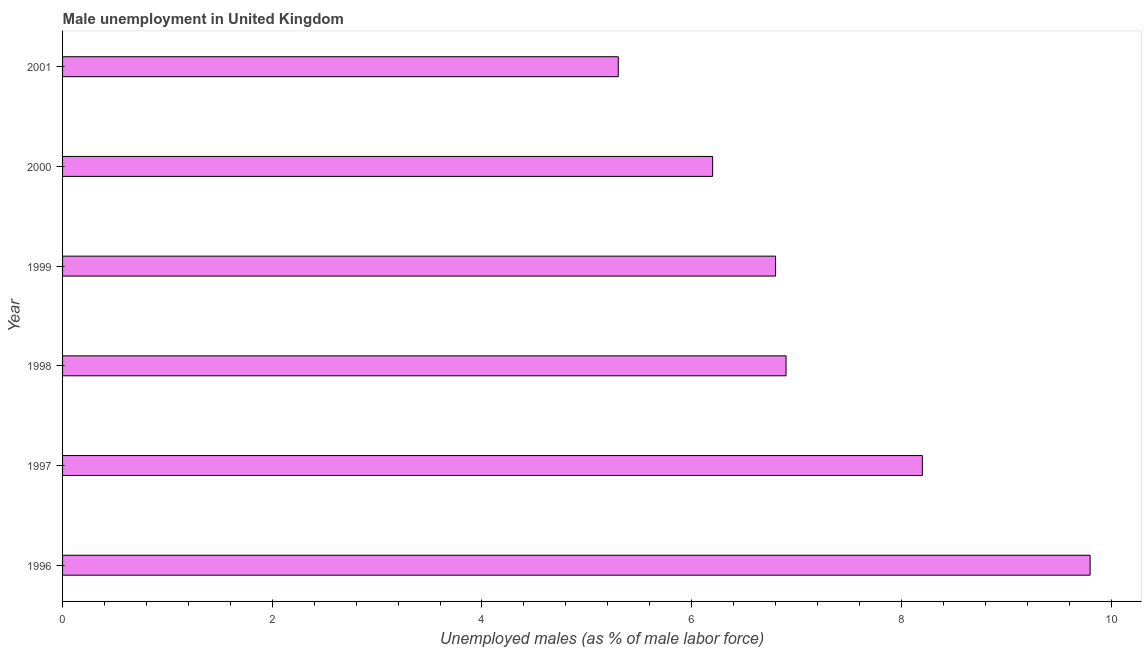What is the title of the graph?
Make the answer very short. Male unemployment in United Kingdom. What is the label or title of the X-axis?
Keep it short and to the point. Unemployed males (as % of male labor force). What is the unemployed males population in 2001?
Give a very brief answer. 5.3. Across all years, what is the maximum unemployed males population?
Offer a very short reply. 9.8. Across all years, what is the minimum unemployed males population?
Your response must be concise. 5.3. In which year was the unemployed males population maximum?
Offer a very short reply. 1996. What is the sum of the unemployed males population?
Make the answer very short. 43.2. What is the difference between the unemployed males population in 1997 and 1998?
Your answer should be very brief. 1.3. What is the average unemployed males population per year?
Make the answer very short. 7.2. What is the median unemployed males population?
Make the answer very short. 6.85. In how many years, is the unemployed males population greater than 1.2 %?
Your response must be concise. 6. What is the ratio of the unemployed males population in 1997 to that in 1999?
Ensure brevity in your answer.  1.21. Is the unemployed males population in 1999 less than that in 2000?
Your response must be concise. No. Is the difference between the unemployed males population in 1997 and 2000 greater than the difference between any two years?
Your answer should be very brief. No. What is the difference between the highest and the second highest unemployed males population?
Offer a terse response. 1.6. How many bars are there?
Your answer should be very brief. 6. Are the values on the major ticks of X-axis written in scientific E-notation?
Your response must be concise. No. What is the Unemployed males (as % of male labor force) of 1996?
Your answer should be very brief. 9.8. What is the Unemployed males (as % of male labor force) in 1997?
Your response must be concise. 8.2. What is the Unemployed males (as % of male labor force) of 1998?
Your answer should be compact. 6.9. What is the Unemployed males (as % of male labor force) in 1999?
Provide a short and direct response. 6.8. What is the Unemployed males (as % of male labor force) of 2000?
Offer a terse response. 6.2. What is the Unemployed males (as % of male labor force) of 2001?
Offer a terse response. 5.3. What is the difference between the Unemployed males (as % of male labor force) in 1996 and 1999?
Make the answer very short. 3. What is the difference between the Unemployed males (as % of male labor force) in 1996 and 2000?
Your answer should be very brief. 3.6. What is the difference between the Unemployed males (as % of male labor force) in 1997 and 2000?
Ensure brevity in your answer.  2. What is the difference between the Unemployed males (as % of male labor force) in 1997 and 2001?
Make the answer very short. 2.9. What is the difference between the Unemployed males (as % of male labor force) in 1998 and 2000?
Your response must be concise. 0.7. What is the difference between the Unemployed males (as % of male labor force) in 1998 and 2001?
Provide a succinct answer. 1.6. What is the difference between the Unemployed males (as % of male labor force) in 1999 and 2000?
Your answer should be compact. 0.6. What is the difference between the Unemployed males (as % of male labor force) in 1999 and 2001?
Make the answer very short. 1.5. What is the difference between the Unemployed males (as % of male labor force) in 2000 and 2001?
Offer a very short reply. 0.9. What is the ratio of the Unemployed males (as % of male labor force) in 1996 to that in 1997?
Offer a very short reply. 1.2. What is the ratio of the Unemployed males (as % of male labor force) in 1996 to that in 1998?
Give a very brief answer. 1.42. What is the ratio of the Unemployed males (as % of male labor force) in 1996 to that in 1999?
Keep it short and to the point. 1.44. What is the ratio of the Unemployed males (as % of male labor force) in 1996 to that in 2000?
Provide a short and direct response. 1.58. What is the ratio of the Unemployed males (as % of male labor force) in 1996 to that in 2001?
Ensure brevity in your answer.  1.85. What is the ratio of the Unemployed males (as % of male labor force) in 1997 to that in 1998?
Your answer should be very brief. 1.19. What is the ratio of the Unemployed males (as % of male labor force) in 1997 to that in 1999?
Ensure brevity in your answer.  1.21. What is the ratio of the Unemployed males (as % of male labor force) in 1997 to that in 2000?
Ensure brevity in your answer.  1.32. What is the ratio of the Unemployed males (as % of male labor force) in 1997 to that in 2001?
Provide a short and direct response. 1.55. What is the ratio of the Unemployed males (as % of male labor force) in 1998 to that in 2000?
Your answer should be very brief. 1.11. What is the ratio of the Unemployed males (as % of male labor force) in 1998 to that in 2001?
Your answer should be compact. 1.3. What is the ratio of the Unemployed males (as % of male labor force) in 1999 to that in 2000?
Ensure brevity in your answer.  1.1. What is the ratio of the Unemployed males (as % of male labor force) in 1999 to that in 2001?
Give a very brief answer. 1.28. What is the ratio of the Unemployed males (as % of male labor force) in 2000 to that in 2001?
Your response must be concise. 1.17. 